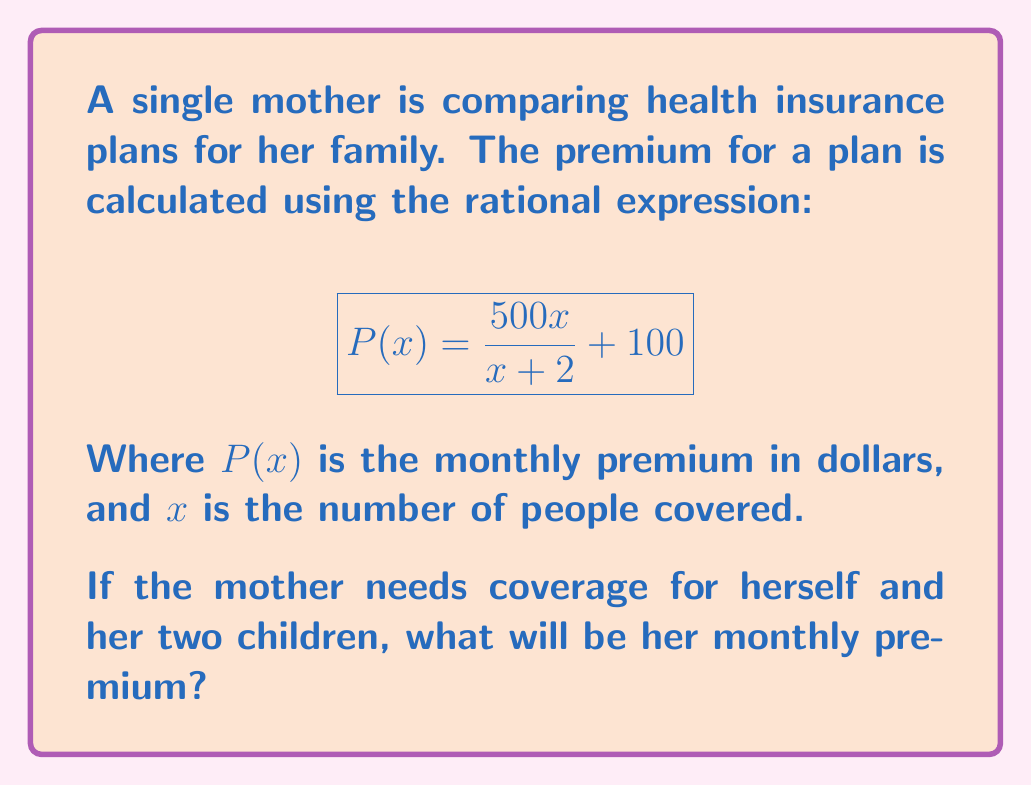Can you answer this question? Let's approach this step-by-step:

1) We need to find $P(3)$ since the coverage is for 3 people (the mother and her two children).

2) Substitute $x=3$ into the given rational expression:

   $$P(3) = \frac{500(3)}{3+2} + 100$$

3) Simplify the numerator:
   
   $$P(3) = \frac{1500}{3+2} + 100$$

4) Simplify the denominator:
   
   $$P(3) = \frac{1500}{5} + 100$$

5) Divide 1500 by 5:
   
   $$P(3) = 300 + 100$$

6) Add the final terms:
   
   $$P(3) = 400$$

Therefore, the monthly premium for the mother and her two children will be $400.
Answer: $400 